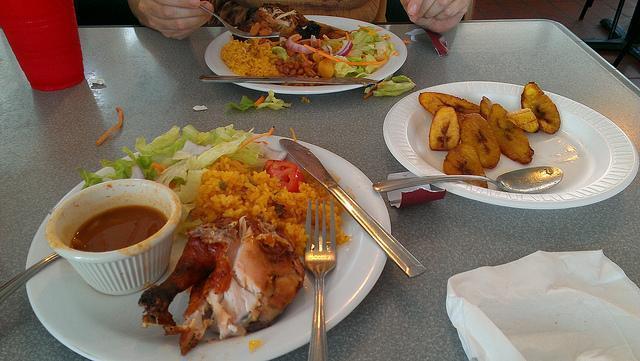How many dining tables can you see?
Give a very brief answer. 1. 